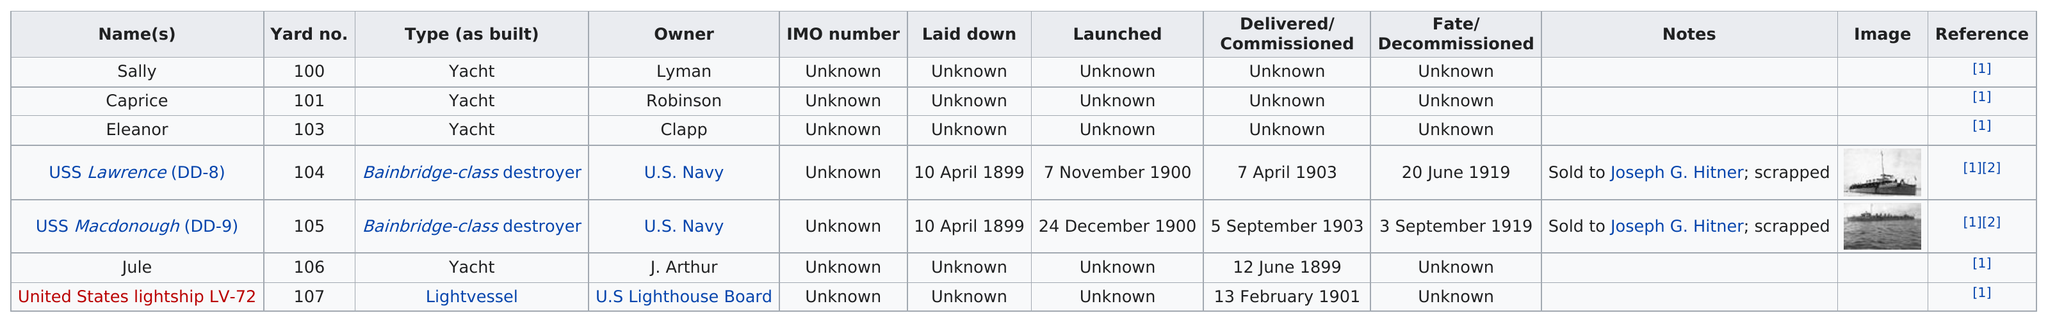Highlight a few significant elements in this photo. The USS Lawrence (DD-8) was launched before December 1900, making it the first Bainbridge-class destroyer. The United States lightship LV-72 is the only ship in this yard that was built as a light vessel. The previous ship that was built before the Caprice in the shipyard was named Sally. The USS Lawrence (DD-8) was not built as a yacht. The difference in yard numbers between Eleanor and Caprice is 2. 